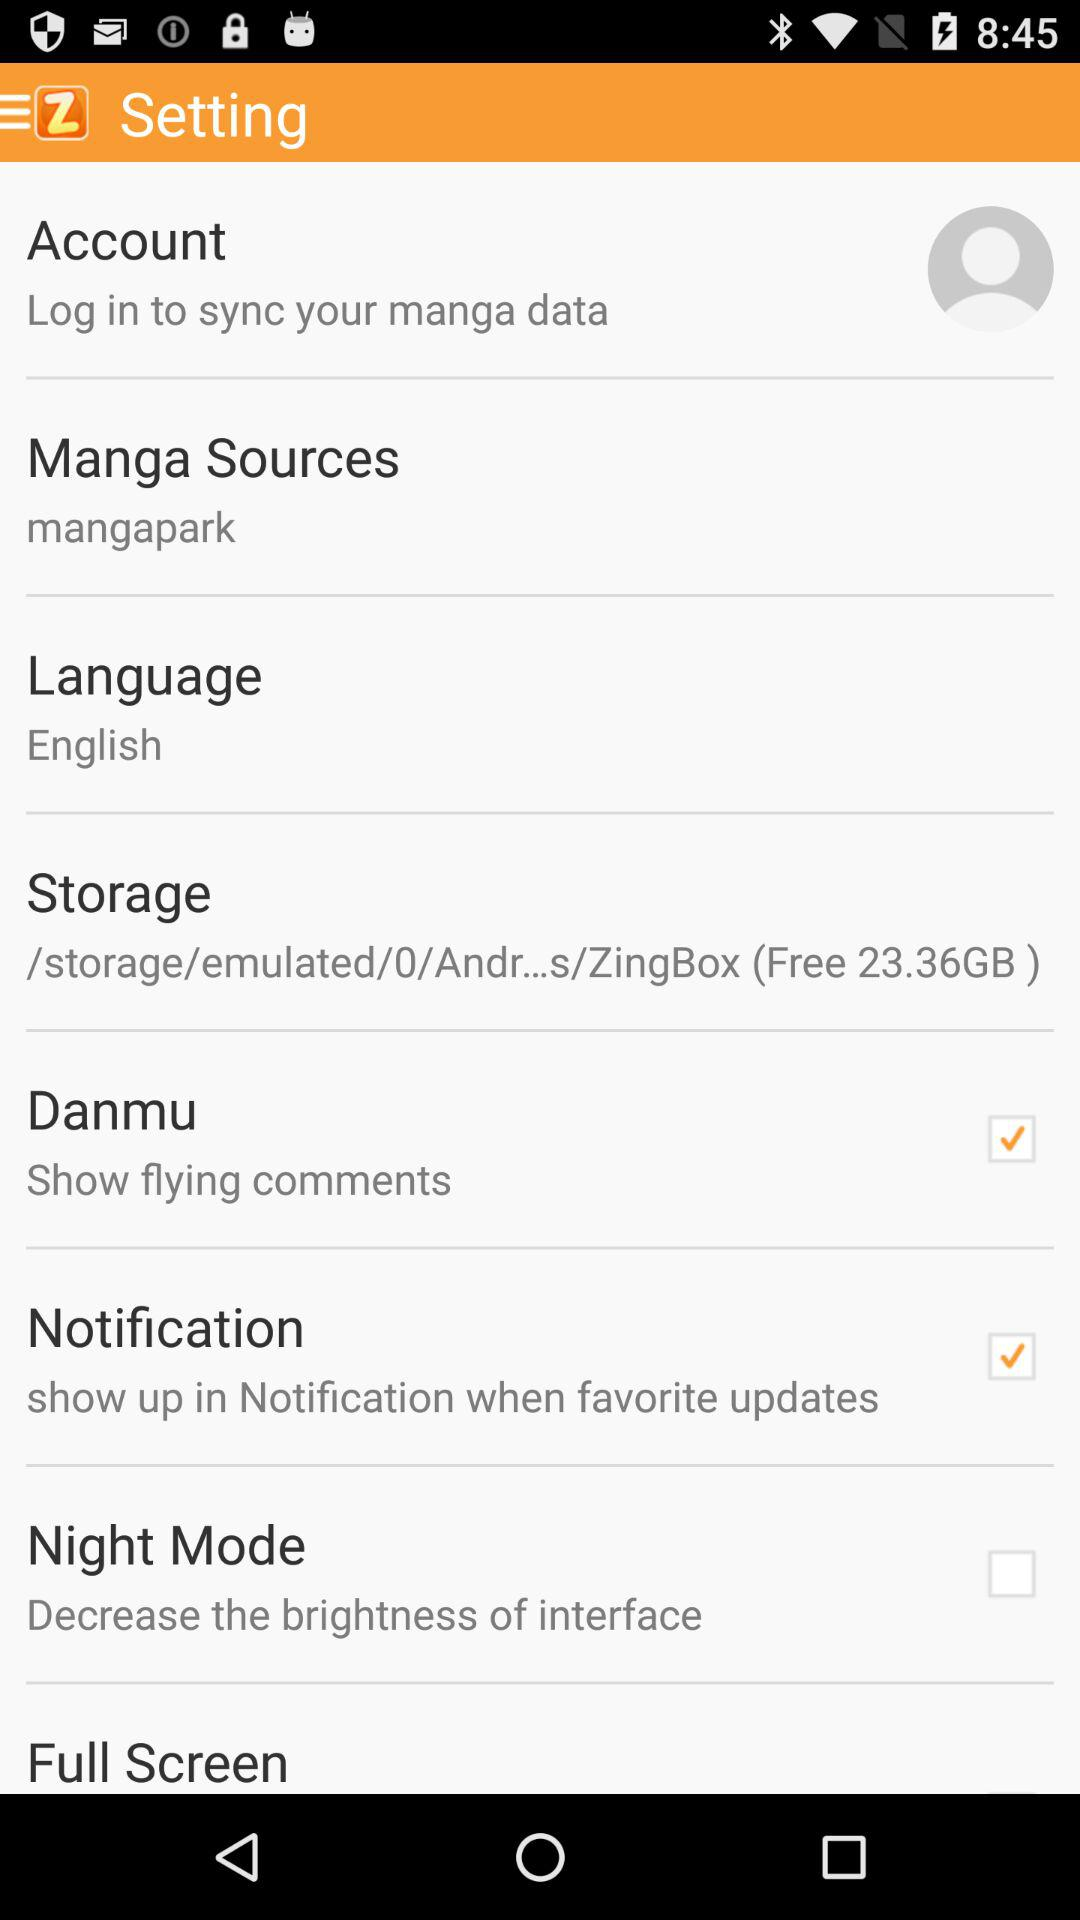Which options are selected? The selected options are "Danmu" and "Notification". 